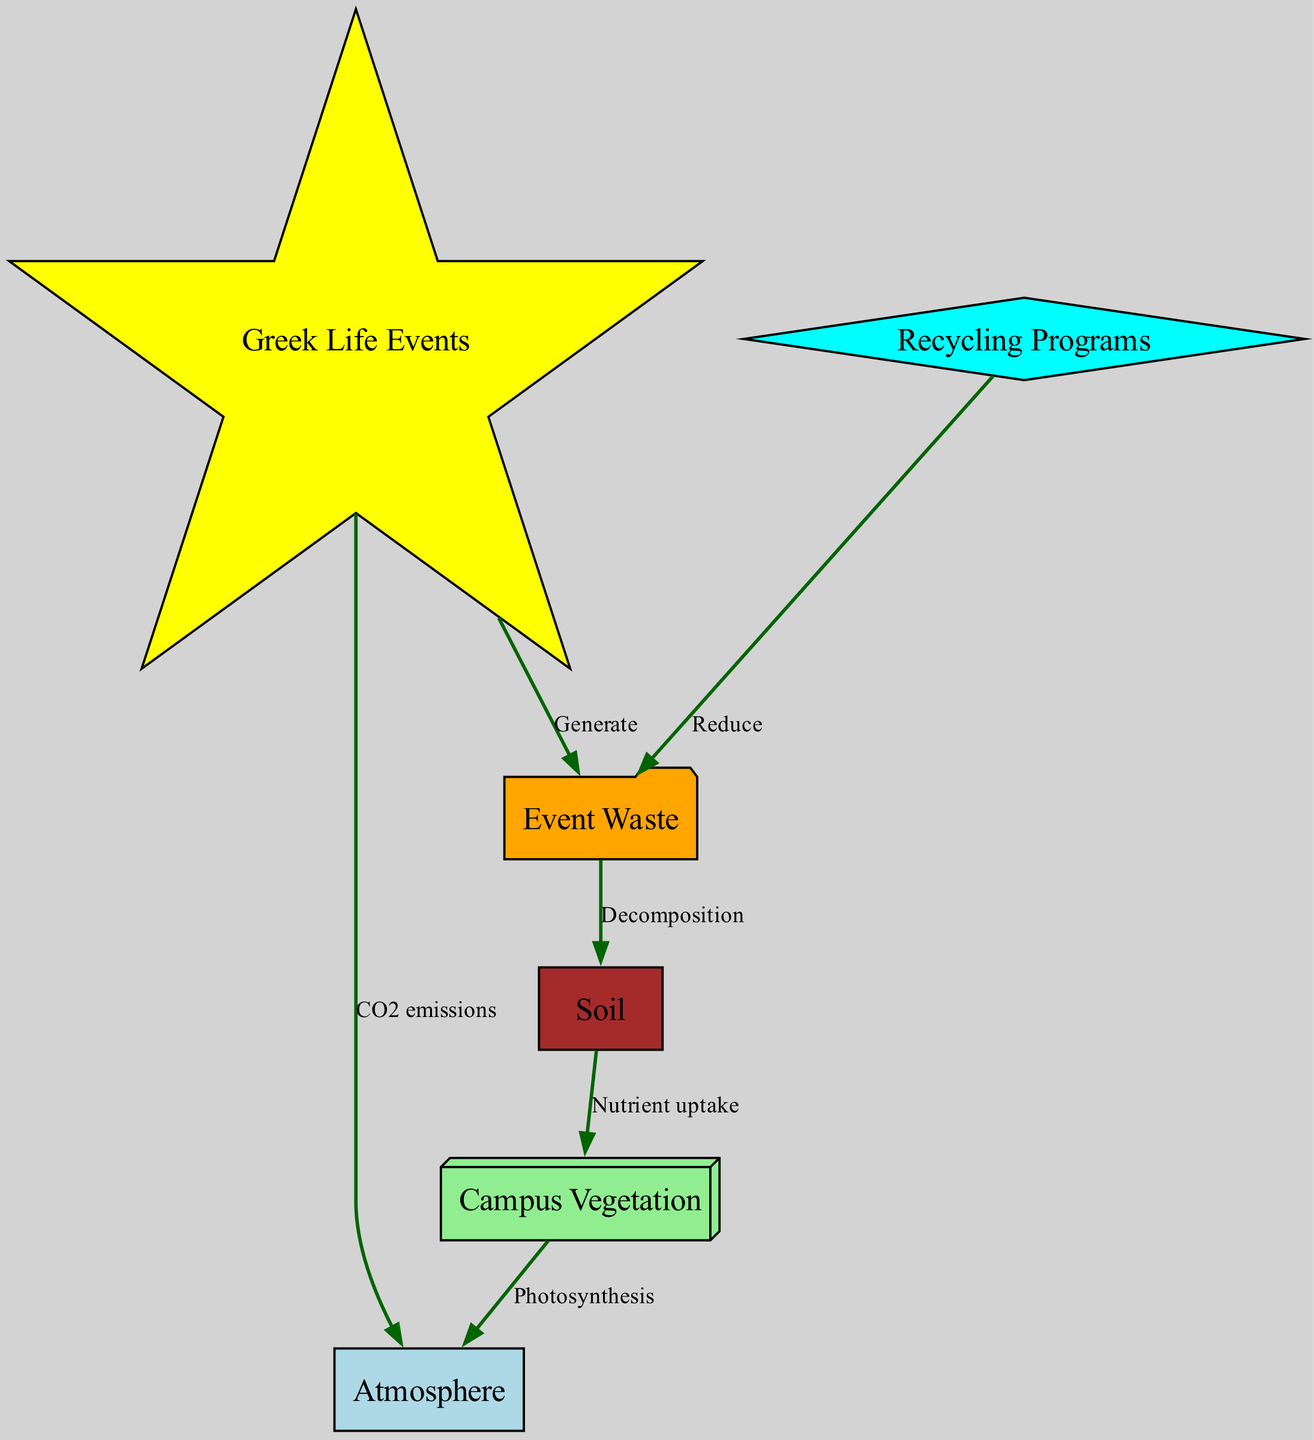What is generated from Greek Life events? The diagram indicates that Greek Life events generate waste which is represented by the directed edge from the "events" node to the "waste" node.
Answer: Event Waste How many nodes are in the diagram? By counting the nodes listed in the data, there are six nodes present: atmosphere, campus vegetation, soil, Greek Life events, event waste, and recycling programs.
Answer: 6 What type of emissions are produced by Greek Life events? The label on the edge leading from "events" to "atmosphere" specifically states that Greek Life events produce CO2 emissions.
Answer: CO2 emissions Which node provides nutrients to vegetation? The directed edge from "soil" to "vegetation" indicates that nutrients are taken up from the soil by the vegetation.
Answer: Soil What role do recycling programs play in the diagram? The diagram shows that recycling programs reduce waste, which is illustrated by the edge connecting "recycling" to "waste" with the label "Reduce."
Answer: Reduce If waste decomposes, what does it affect? According to the diagram, waste decomposes and affects the soil, as represented by the edge from "waste" to "soil" labeled "Decomposition."
Answer: Soil How does vegetation contribute to the atmosphere? The diagram demonstrates that vegetation contributes to the atmosphere by photosynthesis, as described in the edge from "vegetation" to "atmosphere" labeled "Photosynthesis."
Answer: Photosynthesis Which node has connections to two different nodes, and what are they? The "waste" node has connections to two nodes: it generates from "events" and it decomposes to affect "soil."
Answer: Events, Soil What happens to nutrients from soil? Nutrients from soil are taken up by vegetation, as illustrated by the edge going from "soil" to "vegetation" labeled "Nutrient uptake."
Answer: Nutrient uptake 